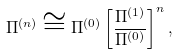Convert formula to latex. <formula><loc_0><loc_0><loc_500><loc_500>\Pi ^ { ( n ) } \cong \Pi ^ { ( 0 ) } \left [ \frac { \Pi ^ { ( 1 ) } } { \Pi ^ { ( 0 ) } } \right ] ^ { n } ,</formula> 